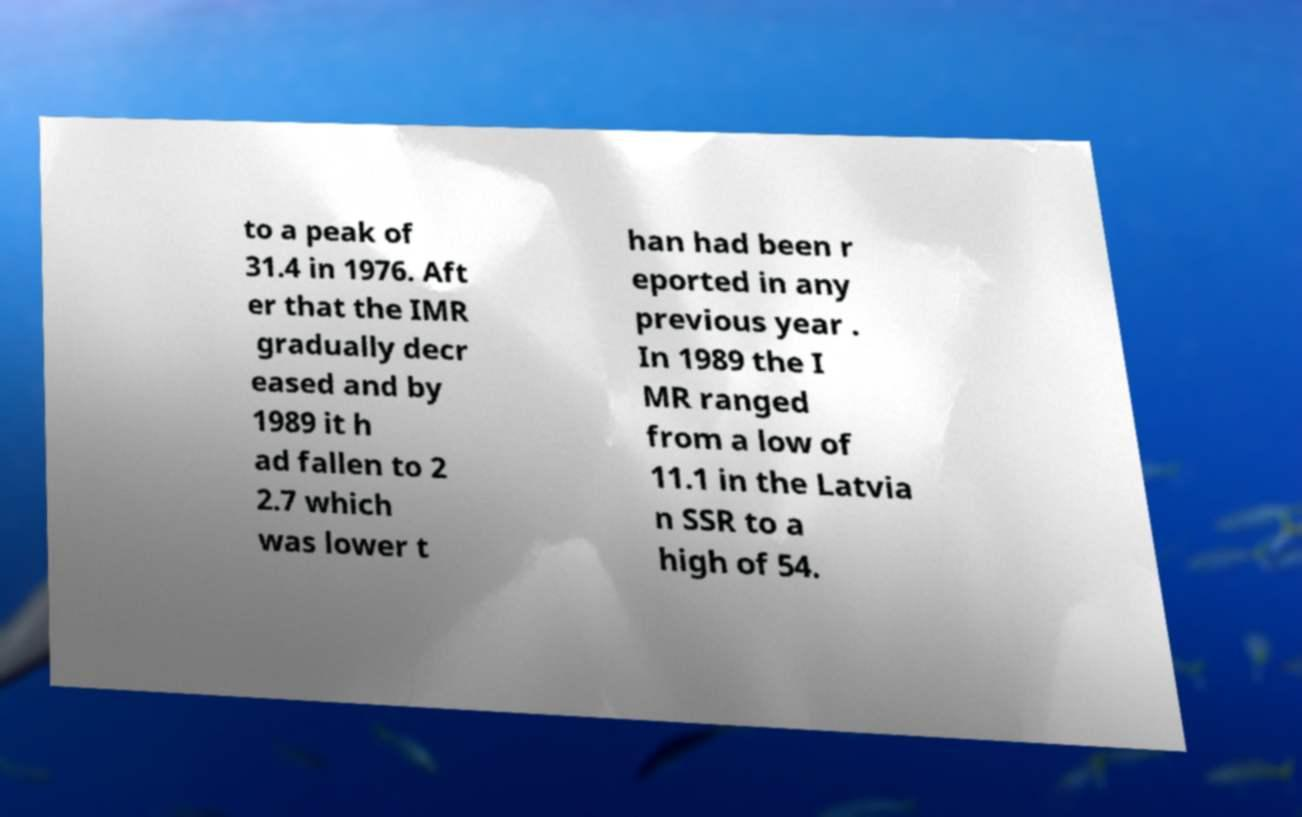I need the written content from this picture converted into text. Can you do that? to a peak of 31.4 in 1976. Aft er that the IMR gradually decr eased and by 1989 it h ad fallen to 2 2.7 which was lower t han had been r eported in any previous year . In 1989 the I MR ranged from a low of 11.1 in the Latvia n SSR to a high of 54. 